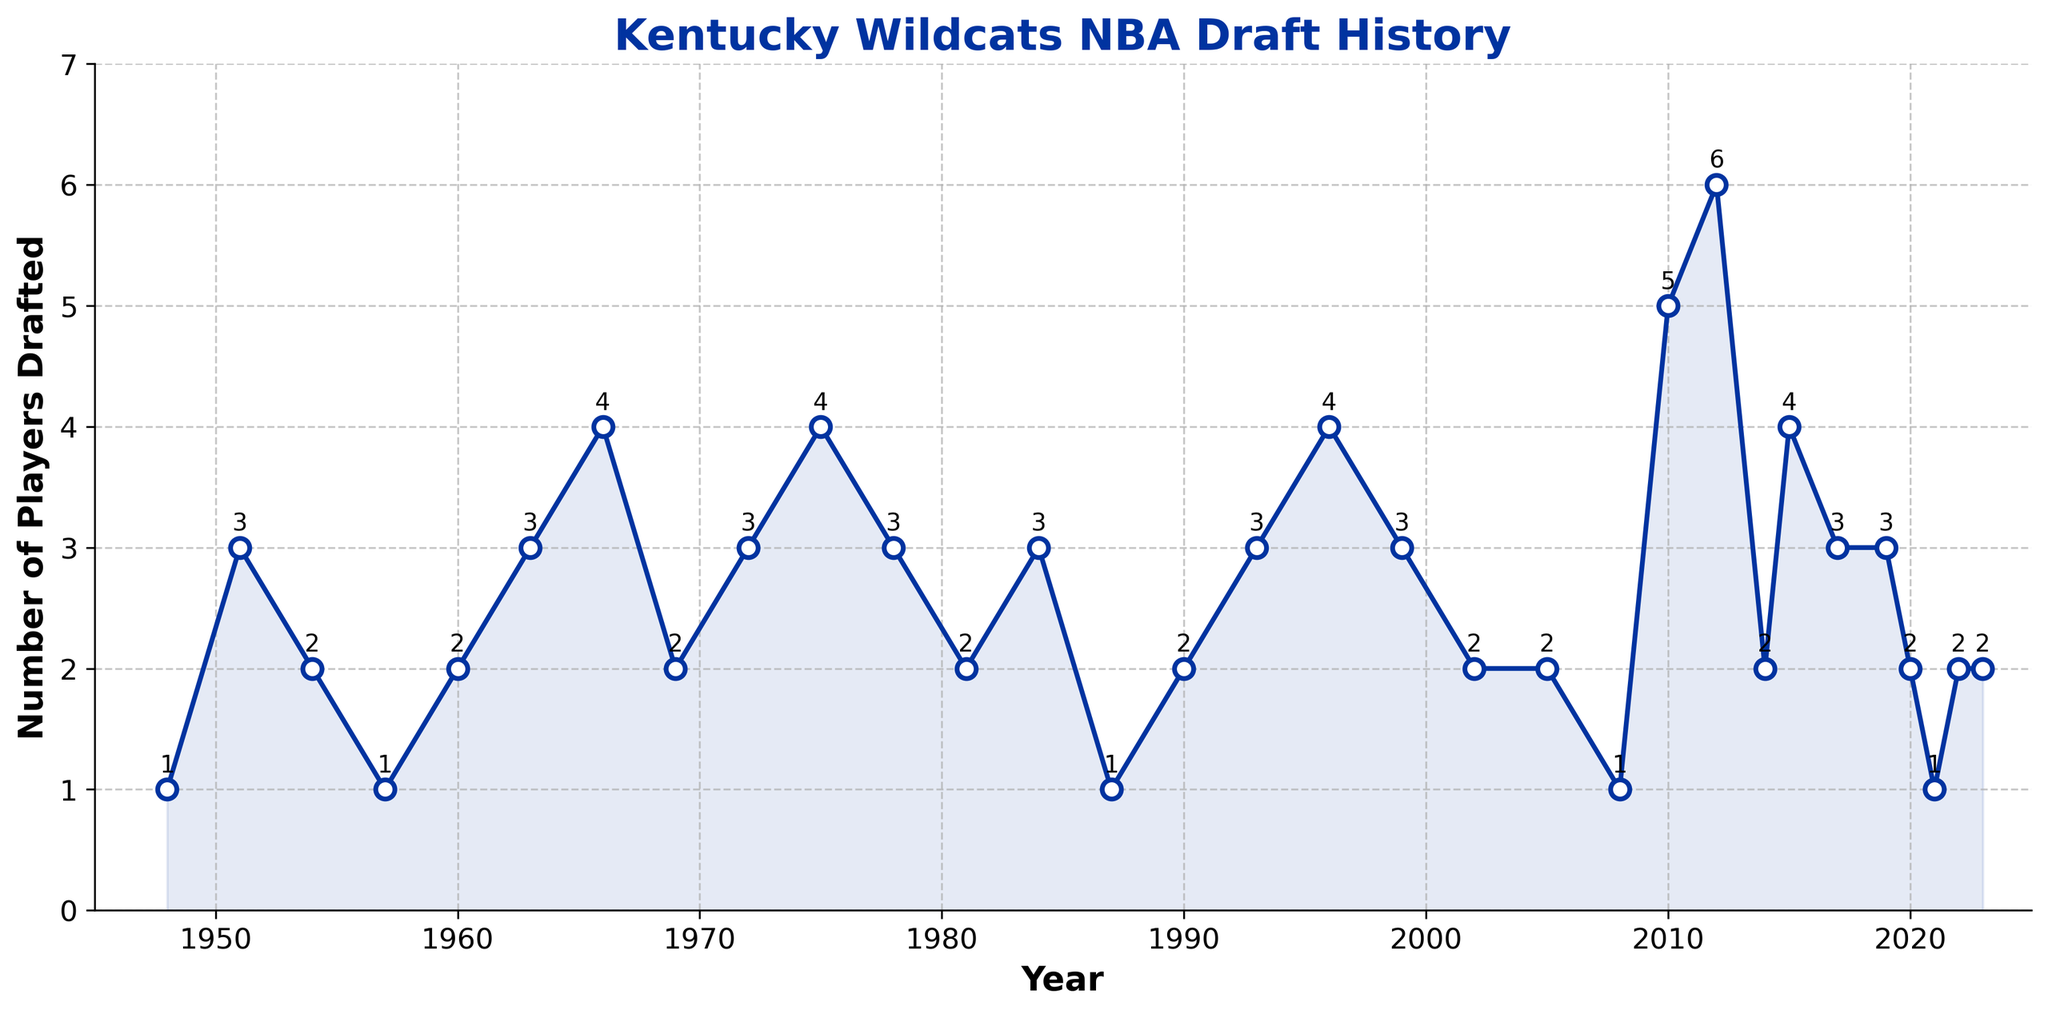What is the first year shown on the chart where Kentucky Wildcats players were drafted into the NBA? The chart displays the number of Kentucky Wildcats players drafted into the NBA each year. The first year shown on the chart is the earliest data point, which is 1948.
Answer: 1948 Which year had the highest number of players drafted? To find this, look for the peak point on the graph. The year with the highest number of players drafted is 2012, where 6 players were drafted.
Answer: 2012 How many players in total were drafted in the 1960s? To determine this, add the number of players for each year in the 1960s: 1960 (2), 1963 (3), 1966 (4), 1969 (2). The total is 2 + 3 + 4 + 2 = 11.
Answer: 11 Between 2010 and 2020, which year had fewer players drafted, and how many were drafted that year? In the given period, check the graph at each year: 2010 (5), 2012 (6), 2014 (2), 2015 (4), 2017 (3), 2019 (3), 2020 (2). The year with fewer players drafted is 2014, with 2 players.
Answer: 2014 (2) Compare the number of players drafted in 1996 to 2021. Which year had more players drafted? Look at the data points for 1996 (4) and 2021 (1). 1996 had more players drafted than 2021.
Answer: 1996 What is the average number of players drafted per year from 2000 to 2020? Consider the years from 2000 to 2020, and sum the number of players drafted each year: 2002 (2), 2005 (2), 2008 (1), 2010 (5), 2012 (6), 2014 (2), 2015 (4), 2017 (3), 2019 (3), 2020 (2). The sum is 30, and there are 10 data points. Thus, the average is 30/10 = 3.
Answer: 3 In which year(s) did the Kentucky Wildcats have exactly 4 players drafted? Identify the points on the graph where the y-value is 4. These years are 1966, 1975, 1996, and 2015.
Answer: 1966, 1975, 1996, 2015 Did the number of players drafted increase or decrease from 1951 to 1954? Compare the values from 1951 (3) and 1954 (2). The number decreased from 3 to 2.
Answer: Decrease What is the total number of players drafted from 1980 to 1990? Sum the values for the given years: 1981 (2), 1984 (3), 1987 (1), 1990 (2). The total is 2 + 3 + 1 + 2 = 8.
Answer: 8 How often did the number of players drafted exceed 4 within the entire data range? Investigate the graph for points where the value is greater than 4. These years are 2010 (5) and 2012 (6). This happened 2 times.
Answer: 2 